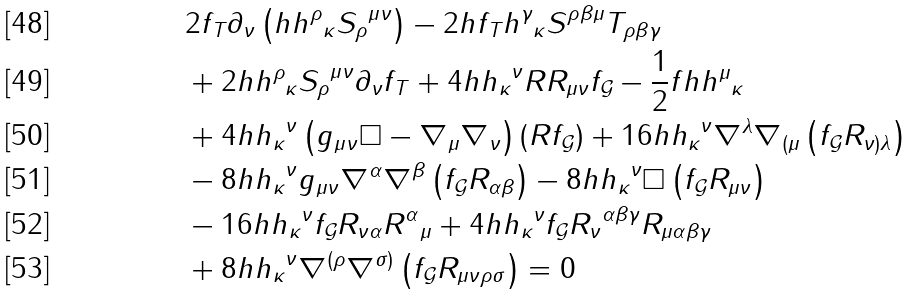Convert formula to latex. <formula><loc_0><loc_0><loc_500><loc_500>& 2 { f _ { T } } { \partial _ { \nu } } \left ( { h { h ^ { \rho } } _ { \kappa } { S _ { \rho } } ^ { \mu \nu } } \right ) - 2 h { f _ { T } } { h ^ { \gamma } } _ { \kappa } { S ^ { \rho \beta \mu } } { T _ { \rho \beta \gamma } } \\ & + 2 h { h ^ { \rho } } _ { \kappa } { S _ { \rho } } ^ { \mu \nu } { \partial _ { \nu } } { f _ { T } } + 4 h { h _ { \kappa } } ^ { \nu } R { R _ { \mu \nu } } { f _ { \mathcal { G } } } - \frac { 1 } { 2 } f h { h ^ { \mu } } _ { \kappa } \\ & + 4 h { h _ { \kappa } } ^ { \nu } \left ( { { g _ { \mu \nu } } \square - { \nabla _ { \mu } } { \nabla _ { \nu } } } \right ) \left ( { R { f _ { \mathcal { G } } } } \right ) + 1 6 h { h _ { \kappa } } ^ { \nu } { \nabla ^ { \lambda } } { \nabla _ { ( \mu } } \left ( { { f _ { \mathcal { G } } } { R _ { \nu ) \lambda } } } \right ) \\ & - 8 h { h _ { \kappa } } ^ { \nu } { g _ { \mu \nu } } { \nabla ^ { \alpha } } { \nabla ^ { \beta } } \left ( { { f _ { \mathcal { G } } } { R _ { \alpha \beta } } } \right ) - 8 h { h _ { \kappa } } ^ { \nu } \square \left ( { { f _ { \mathcal { G } } } { R _ { \mu \nu } } } \right ) \\ & - 1 6 h { h _ { \kappa } } ^ { \nu } { f _ { \mathcal { G } } } { R _ { \nu \alpha } } { R ^ { \alpha } } _ { \mu } + 4 h { h _ { \kappa } } ^ { \nu } { f _ { \mathcal { G } } } { R _ { \nu } } ^ { \alpha \beta \gamma } { R _ { \mu \alpha \beta \gamma } } \\ & + 8 h { h _ { \kappa } } ^ { \nu } { \nabla ^ { ( \rho } } { \nabla ^ { \sigma ) } } \left ( { { f _ { \mathcal { G } } } { R _ { \mu \nu \rho \sigma } } } \right ) = 0</formula> 